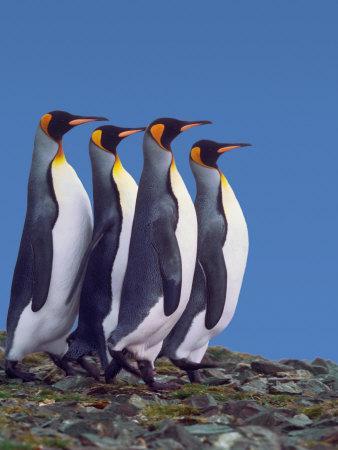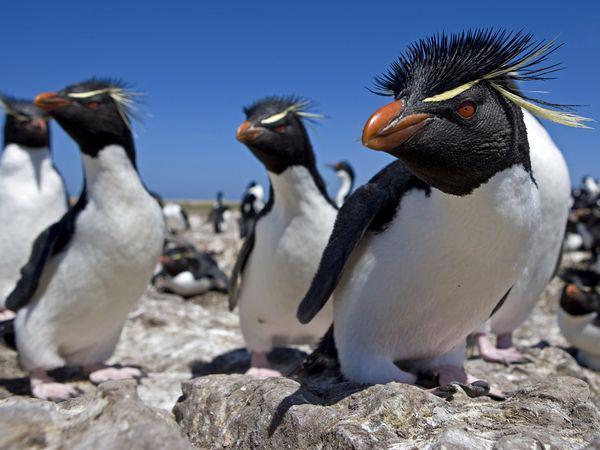The first image is the image on the left, the second image is the image on the right. Assess this claim about the two images: "A waddle of penguins is standing in a snowy landscape in one of the images.". Correct or not? Answer yes or no. No. The first image is the image on the left, the second image is the image on the right. For the images shown, is this caption "The right image has the waters edge visible." true? Answer yes or no. No. The first image is the image on the left, the second image is the image on the right. Analyze the images presented: Is the assertion "At least one image has no more than two penguins." valid? Answer yes or no. No. 